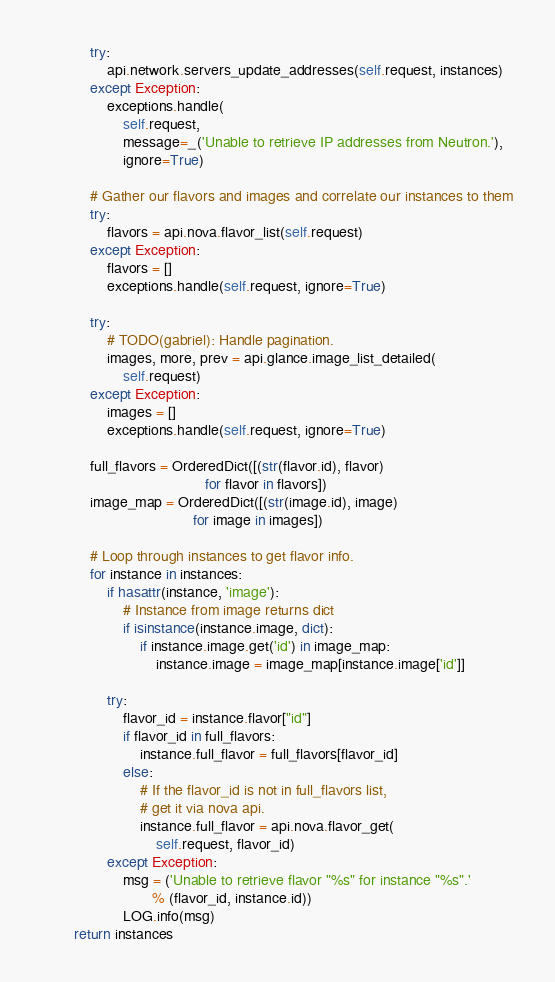<code> <loc_0><loc_0><loc_500><loc_500><_Python_>            try:
                api.network.servers_update_addresses(self.request, instances)
            except Exception:
                exceptions.handle(
                    self.request,
                    message=_('Unable to retrieve IP addresses from Neutron.'),
                    ignore=True)

            # Gather our flavors and images and correlate our instances to them
            try:
                flavors = api.nova.flavor_list(self.request)
            except Exception:
                flavors = []
                exceptions.handle(self.request, ignore=True)

            try:
                # TODO(gabriel): Handle pagination.
                images, more, prev = api.glance.image_list_detailed(
                    self.request)
            except Exception:
                images = []
                exceptions.handle(self.request, ignore=True)

            full_flavors = OrderedDict([(str(flavor.id), flavor)
                                        for flavor in flavors])
            image_map = OrderedDict([(str(image.id), image)
                                     for image in images])

            # Loop through instances to get flavor info.
            for instance in instances:
                if hasattr(instance, 'image'):
                    # Instance from image returns dict
                    if isinstance(instance.image, dict):
                        if instance.image.get('id') in image_map:
                            instance.image = image_map[instance.image['id']]

                try:
                    flavor_id = instance.flavor["id"]
                    if flavor_id in full_flavors:
                        instance.full_flavor = full_flavors[flavor_id]
                    else:
                        # If the flavor_id is not in full_flavors list,
                        # get it via nova api.
                        instance.full_flavor = api.nova.flavor_get(
                            self.request, flavor_id)
                except Exception:
                    msg = ('Unable to retrieve flavor "%s" for instance "%s".'
                           % (flavor_id, instance.id))
                    LOG.info(msg)
        return instances
</code> 